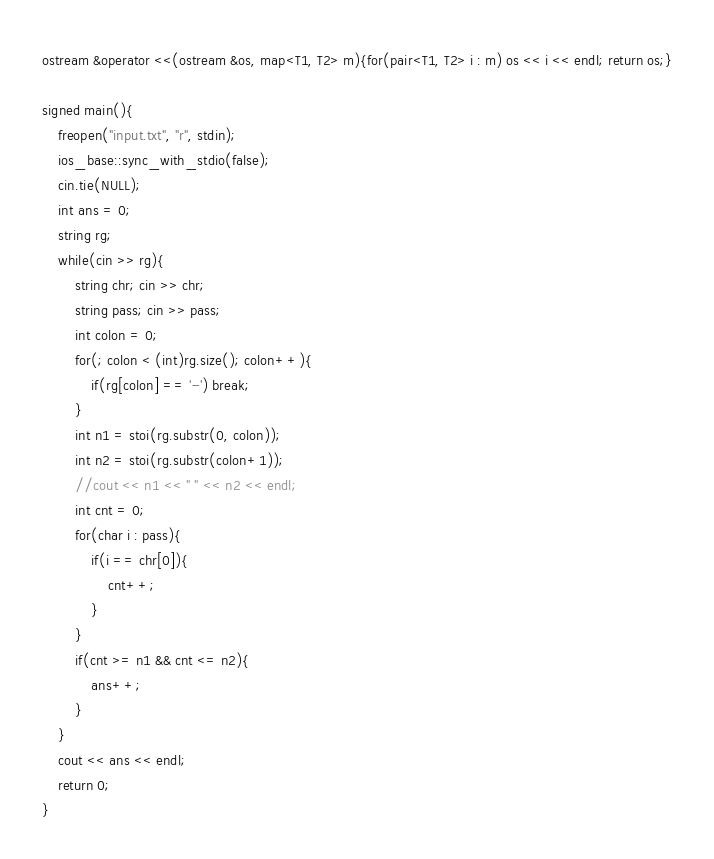Convert code to text. <code><loc_0><loc_0><loc_500><loc_500><_C++_>ostream &operator <<(ostream &os, map<T1, T2> m){for(pair<T1, T2> i : m) os << i << endl; return os;}

signed main(){
    freopen("input.txt", "r", stdin);
    ios_base::sync_with_stdio(false);
    cin.tie(NULL); 
    int ans = 0;
    string rg;
    while(cin >> rg){
        string chr; cin >> chr;
        string pass; cin >> pass;
        int colon = 0;
        for(; colon < (int)rg.size(); colon++){
            if(rg[colon] == '-') break;
        }
        int n1 = stoi(rg.substr(0, colon));
        int n2 = stoi(rg.substr(colon+1));
        //cout << n1 << " " << n2 << endl;
        int cnt = 0;
        for(char i : pass){
            if(i == chr[0]){
                cnt++;
            }
        }
        if(cnt >= n1 && cnt <= n2){
            ans++;
        }
    }
    cout << ans << endl;
    return 0;
}



</code> 